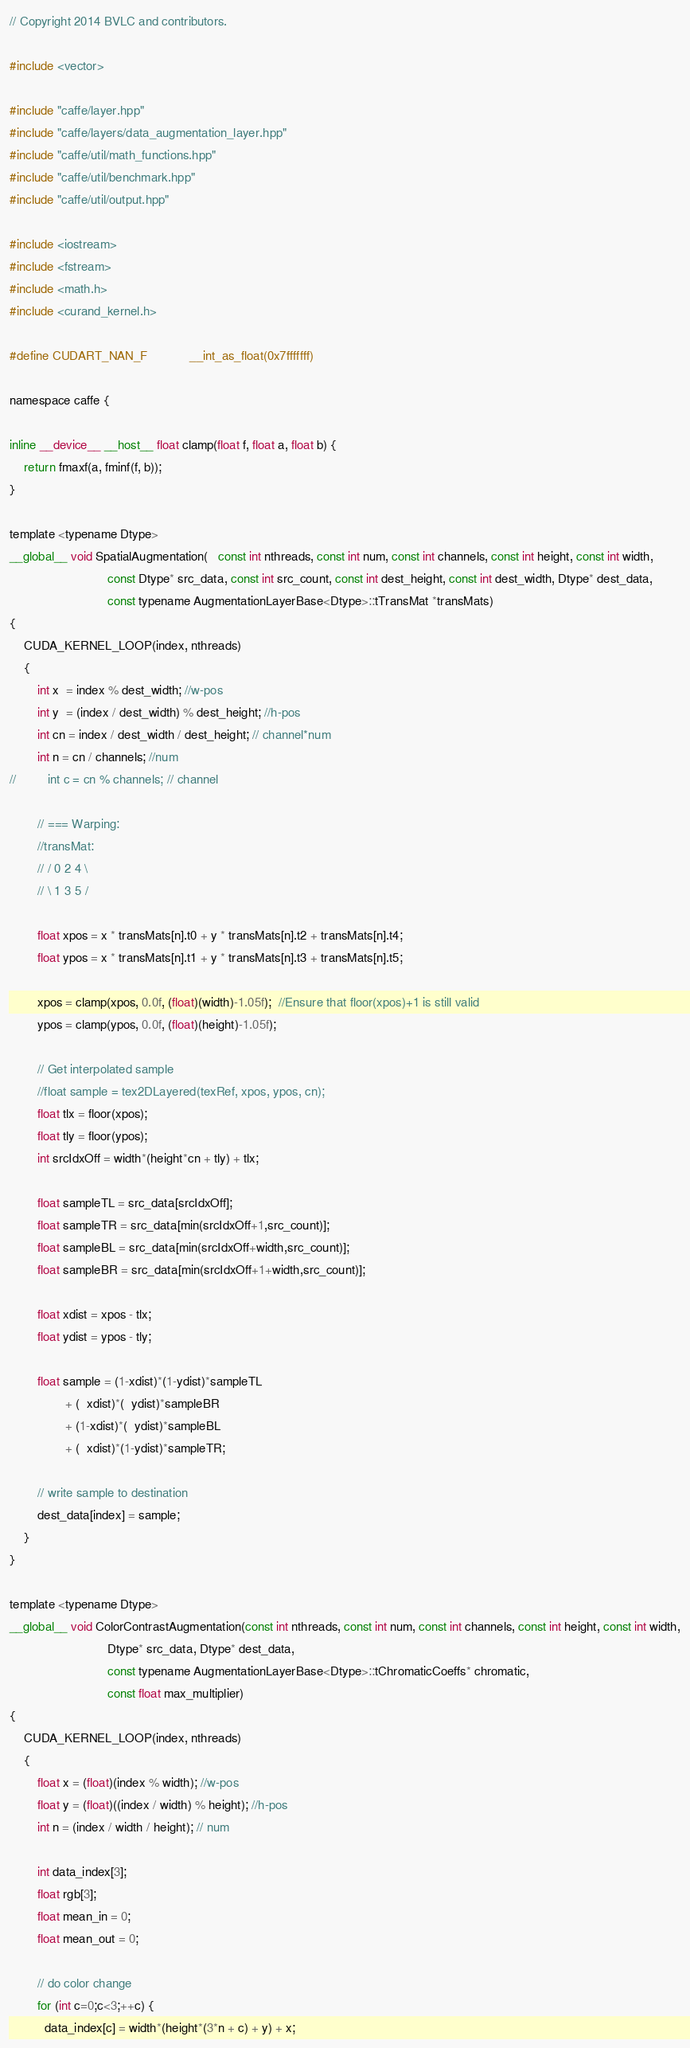Convert code to text. <code><loc_0><loc_0><loc_500><loc_500><_Cuda_>// Copyright 2014 BVLC and contributors.

#include <vector>

#include "caffe/layer.hpp"
#include "caffe/layers/data_augmentation_layer.hpp"
#include "caffe/util/math_functions.hpp"
#include "caffe/util/benchmark.hpp"
#include "caffe/util/output.hpp"

#include <iostream>
#include <fstream>
#include <math.h>
#include <curand_kernel.h>

#define CUDART_NAN_F            __int_as_float(0x7fffffff)

namespace caffe {

inline __device__ __host__ float clamp(float f, float a, float b) {
    return fmaxf(a, fminf(f, b));
}

template <typename Dtype> 
__global__ void SpatialAugmentation(   const int nthreads, const int num, const int channels, const int height, const int width,
                            const Dtype* src_data, const int src_count, const int dest_height, const int dest_width, Dtype* dest_data,
                            const typename AugmentationLayerBase<Dtype>::tTransMat *transMats)
{
    CUDA_KERNEL_LOOP(index, nthreads)
    {
        int x  = index % dest_width; //w-pos
        int y  = (index / dest_width) % dest_height; //h-pos
        int cn = index / dest_width / dest_height; // channel*num
        int n = cn / channels; //num
//         int c = cn % channels; // channel

        // === Warping:
        //transMat:
        // / 0 2 4 \
        // \ 1 3 5 /

        float xpos = x * transMats[n].t0 + y * transMats[n].t2 + transMats[n].t4;
        float ypos = x * transMats[n].t1 + y * transMats[n].t3 + transMats[n].t5;

        xpos = clamp(xpos, 0.0f, (float)(width)-1.05f);  //Ensure that floor(xpos)+1 is still valid
        ypos = clamp(ypos, 0.0f, (float)(height)-1.05f);

        // Get interpolated sample
        //float sample = tex2DLayered(texRef, xpos, ypos, cn);
        float tlx = floor(xpos);
        float tly = floor(ypos);
        int srcIdxOff = width*(height*cn + tly) + tlx;

        float sampleTL = src_data[srcIdxOff];
        float sampleTR = src_data[min(srcIdxOff+1,src_count)];
        float sampleBL = src_data[min(srcIdxOff+width,src_count)];
        float sampleBR = src_data[min(srcIdxOff+1+width,src_count)];

        float xdist = xpos - tlx;
        float ydist = ypos - tly;

        float sample = (1-xdist)*(1-ydist)*sampleTL
                + (  xdist)*(  ydist)*sampleBR
                + (1-xdist)*(  ydist)*sampleBL
                + (  xdist)*(1-ydist)*sampleTR;

        // write sample to destination
        dest_data[index] = sample;
    }
}

template <typename Dtype> 
__global__ void ColorContrastAugmentation(const int nthreads, const int num, const int channels, const int height, const int width,
                            Dtype* src_data, Dtype* dest_data,
                            const typename AugmentationLayerBase<Dtype>::tChromaticCoeffs* chromatic,
                            const float max_multiplier)
{
    CUDA_KERNEL_LOOP(index, nthreads)
    {
        float x = (float)(index % width); //w-pos
        float y = (float)((index / width) % height); //h-pos
        int n = (index / width / height); // num

        int data_index[3];
        float rgb[3];
        float mean_in = 0;
        float mean_out = 0;
               
        // do color change
        for (int c=0;c<3;++c) {
          data_index[c] = width*(height*(3*n + c) + y) + x;</code> 